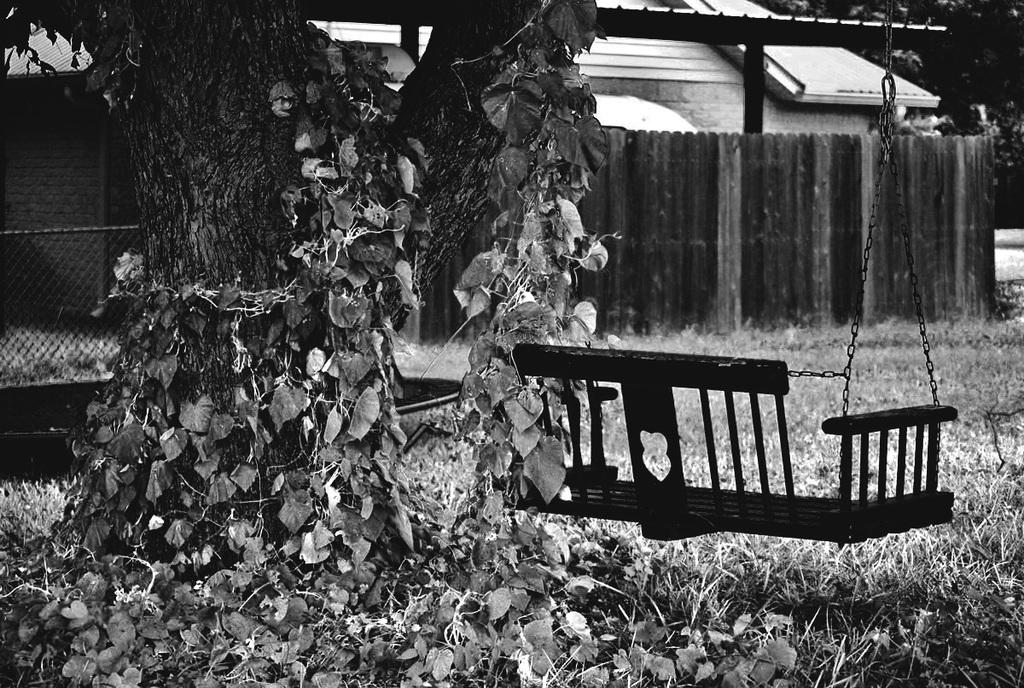What type of vegetation is visible in the image? There are trees in the image. What architectural feature can be seen in the image? There is a fence in the image. What recreational item is present in the image? There is a swing in the image. What type of structure is visible in the image? There is a building in the image. What type of ground surface is present in the image? There is grass in the image. Where is the faucet located in the image? There is no faucet present in the image. What type of activity is the road used for in the image? There is no road present in the image. 